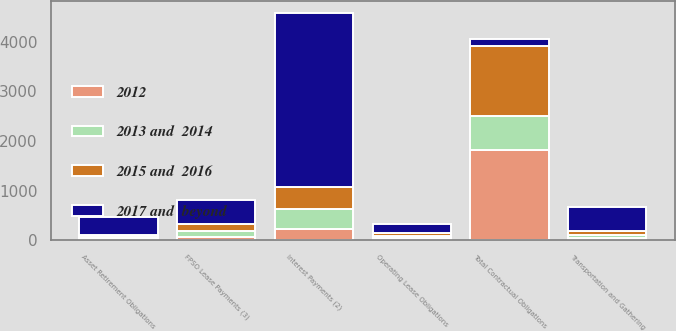Convert chart to OTSL. <chart><loc_0><loc_0><loc_500><loc_500><stacked_bar_chart><ecel><fcel>Interest Payments (2)<fcel>FPSO Lease Payments (3)<fcel>Transportation and Gathering<fcel>Operating Lease Obligations<fcel>Asset Retirement Obligations<fcel>Total Contractual Obligations<nl><fcel>2017 and  beyond<fcel>3502<fcel>486<fcel>466<fcel>185<fcel>377<fcel>144<nl><fcel>2012<fcel>224<fcel>72<fcel>55<fcel>45<fcel>33<fcel>1813<nl><fcel>2015 and  2016<fcel>444<fcel>144<fcel>86<fcel>55<fcel>38<fcel>1416<nl><fcel>2013 and  2014<fcel>417<fcel>115<fcel>58<fcel>53<fcel>28<fcel>684<nl></chart> 